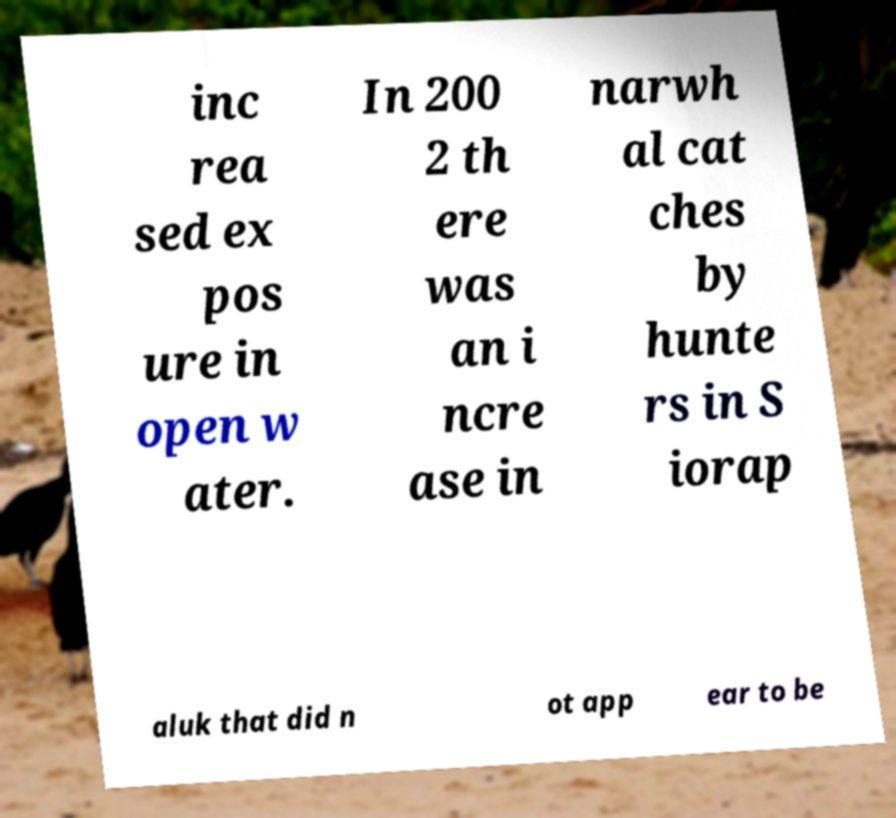For documentation purposes, I need the text within this image transcribed. Could you provide that? inc rea sed ex pos ure in open w ater. In 200 2 th ere was an i ncre ase in narwh al cat ches by hunte rs in S iorap aluk that did n ot app ear to be 